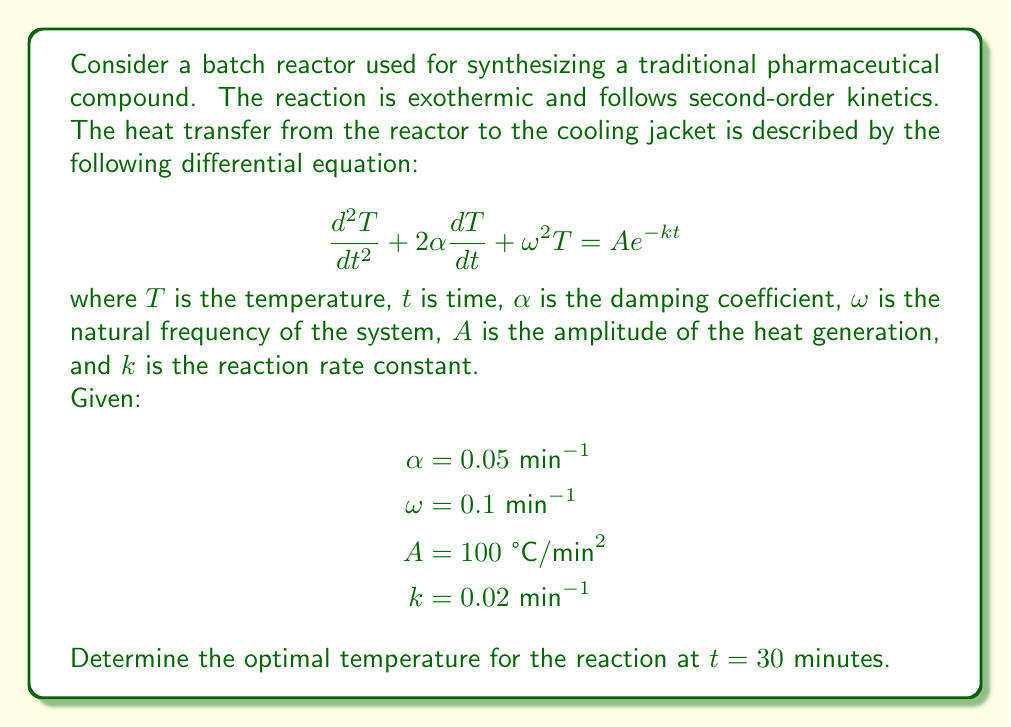Give your solution to this math problem. To solve this problem, we need to find the general solution to the given second-order linear differential equation and then apply the initial conditions.

1. The general solution for this type of equation is:
   $$T(t) = T_h(t) + T_p(t)$$
   where $T_h(t)$ is the homogeneous solution and $T_p(t)$ is the particular solution.

2. The homogeneous solution has the form:
   $$T_h(t) = e^{-\alpha t}(C_1\cos(\beta t) + C_2\sin(\beta t))$$
   where $\beta = \sqrt{\omega^2 - \alpha^2} = \sqrt{0.1^2 - 0.05^2} \approx 0.0866$ min$^{-1}$

3. The particular solution has the form:
   $$T_p(t) = \frac{A}{(\omega^2 - k^2)^2 + 4\alpha^2k^2}e^{-kt}$$

4. Substituting the given values:
   $$T_p(t) = \frac{100}{(0.1^2 - 0.02^2)^2 + 4(0.05^2)(0.02^2)}e^{-0.02t} \approx 10000e^{-0.02t}$$

5. The complete solution is:
   $$T(t) = e^{-0.05t}(C_1\cos(0.0866t) + C_2\sin(0.0866t)) + 10000e^{-0.02t}$$

6. To find $C_1$ and $C_2$, we need initial conditions. Assuming $T(0) = 25$ °C (room temperature) and $\frac{dT}{dt}(0) = 0$ (starting from rest):

   At $t = 0$: $25 = C_1 + 10000$
   $C_1 = -9975$

   $\frac{dT}{dt}(0) = -0.05C_1 + 0.0866C_2 - 200 = 0$
   $C_2 \approx 2244.8$

7. The final solution is:
   $$T(t) = e^{-0.05t}(-9975\cos(0.0866t) + 2244.8\sin(0.0866t)) + 10000e^{-0.02t}$$

8. At $t = 30$ minutes:
   $$T(30) \approx e^{-1.5}(-9975\cos(2.598) + 2244.8\sin(2.598)) + 10000e^{-0.6}$$
   $$T(30) \approx 5490.7 \text{ °C}$$

This temperature represents the optimal temperature for the reaction at t = 30 minutes, balancing the heat generated by the exothermic reaction and the heat removed by the cooling jacket.
Answer: The optimal temperature for the reaction at t = 30 minutes is approximately 5490.7 °C. 